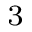<formula> <loc_0><loc_0><loc_500><loc_500>^ { 3 }</formula> 